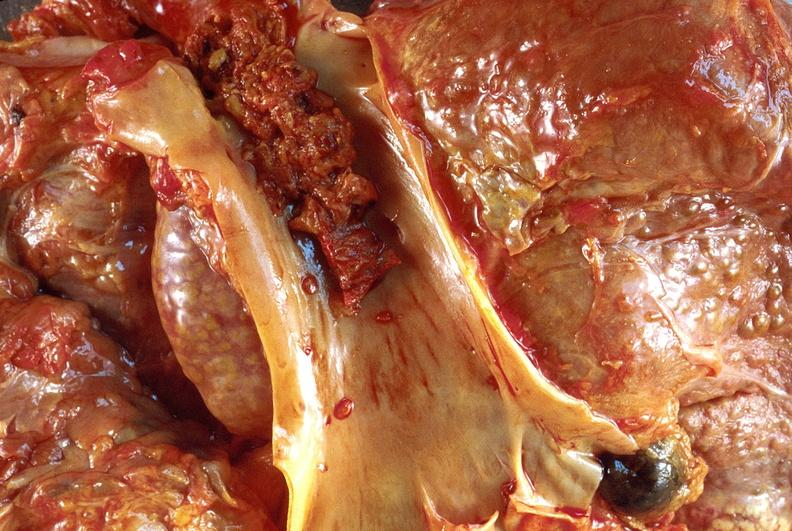what is present?
Answer the question using a single word or phrase. Liver 